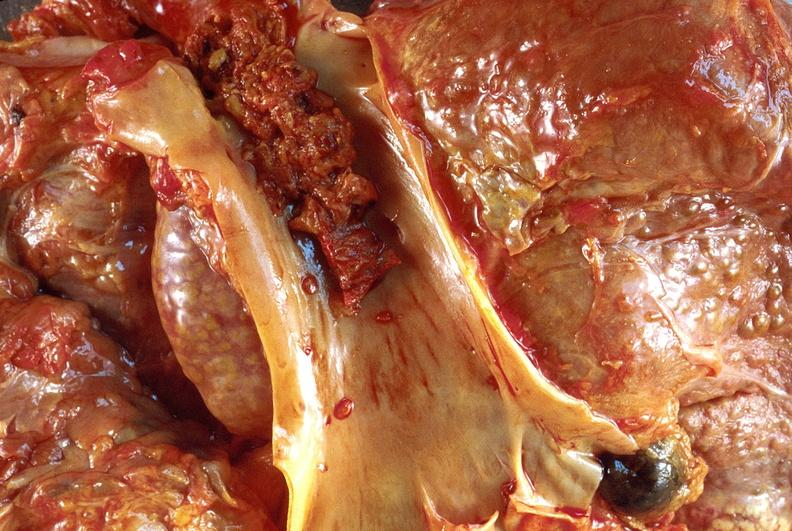what is present?
Answer the question using a single word or phrase. Liver 